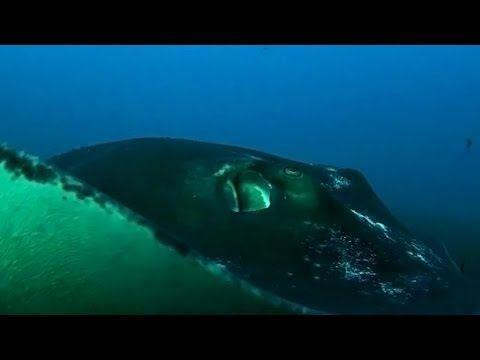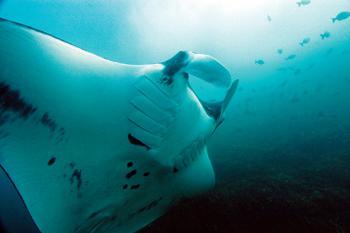The first image is the image on the left, the second image is the image on the right. For the images shown, is this caption "There is a manta ray." true? Answer yes or no. Yes. The first image is the image on the left, the second image is the image on the right. Given the left and right images, does the statement "There are at least two stingrays visible in the right image." hold true? Answer yes or no. No. 